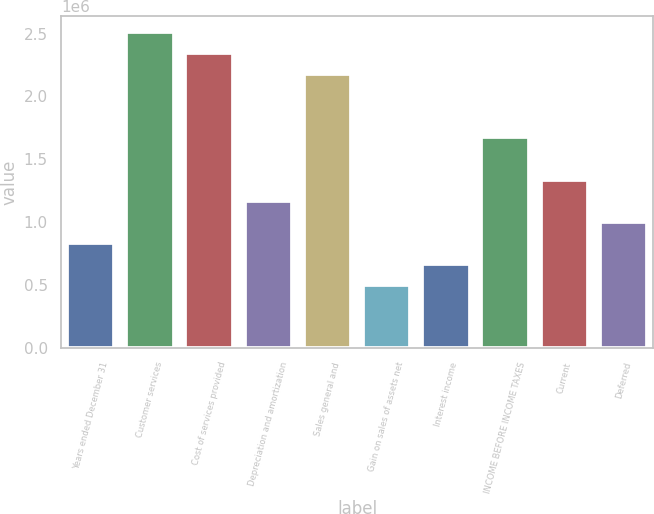Convert chart to OTSL. <chart><loc_0><loc_0><loc_500><loc_500><bar_chart><fcel>Years ended December 31<fcel>Customer services<fcel>Cost of services provided<fcel>Depreciation and amortization<fcel>Sales general and<fcel>Gain on sales of assets net<fcel>Interest income<fcel>INCOME BEFORE INCOME TAXES<fcel>Current<fcel>Deferred<nl><fcel>836979<fcel>2.51094e+06<fcel>2.34354e+06<fcel>1.17177e+06<fcel>2.17614e+06<fcel>502187<fcel>669583<fcel>1.67396e+06<fcel>1.33917e+06<fcel>1.00437e+06<nl></chart> 